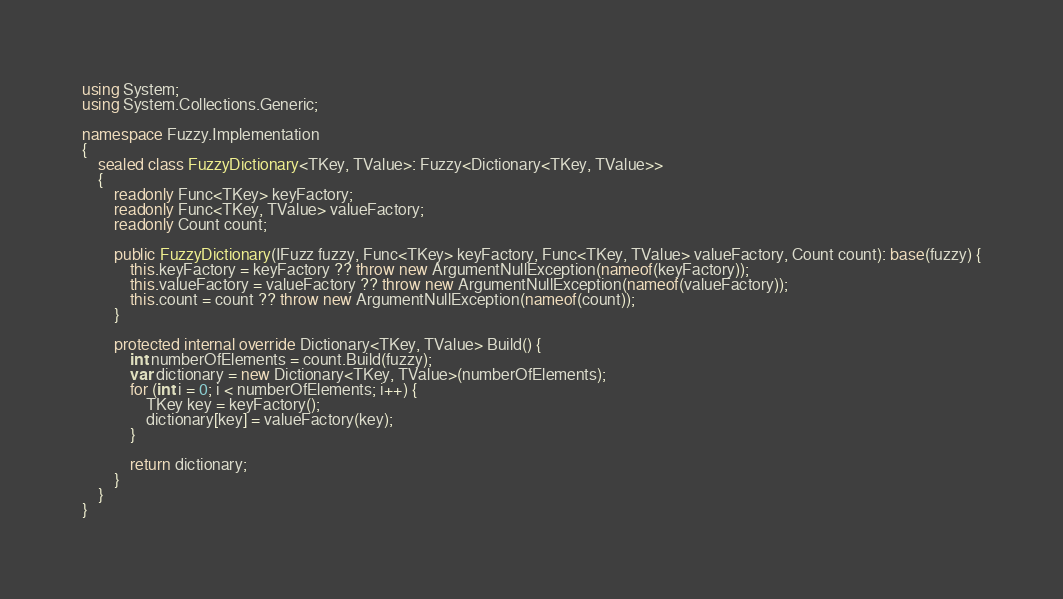<code> <loc_0><loc_0><loc_500><loc_500><_C#_>using System;
using System.Collections.Generic;

namespace Fuzzy.Implementation
{
    sealed class FuzzyDictionary<TKey, TValue>: Fuzzy<Dictionary<TKey, TValue>>
    {
        readonly Func<TKey> keyFactory;
        readonly Func<TKey, TValue> valueFactory;
        readonly Count count;

        public FuzzyDictionary(IFuzz fuzzy, Func<TKey> keyFactory, Func<TKey, TValue> valueFactory, Count count): base(fuzzy) {
            this.keyFactory = keyFactory ?? throw new ArgumentNullException(nameof(keyFactory));
            this.valueFactory = valueFactory ?? throw new ArgumentNullException(nameof(valueFactory));
            this.count = count ?? throw new ArgumentNullException(nameof(count));
        }

        protected internal override Dictionary<TKey, TValue> Build() {
            int numberOfElements = count.Build(fuzzy);
            var dictionary = new Dictionary<TKey, TValue>(numberOfElements);
            for (int i = 0; i < numberOfElements; i++) {
                TKey key = keyFactory();
                dictionary[key] = valueFactory(key);
            }

            return dictionary;
        }
    }
}
</code> 